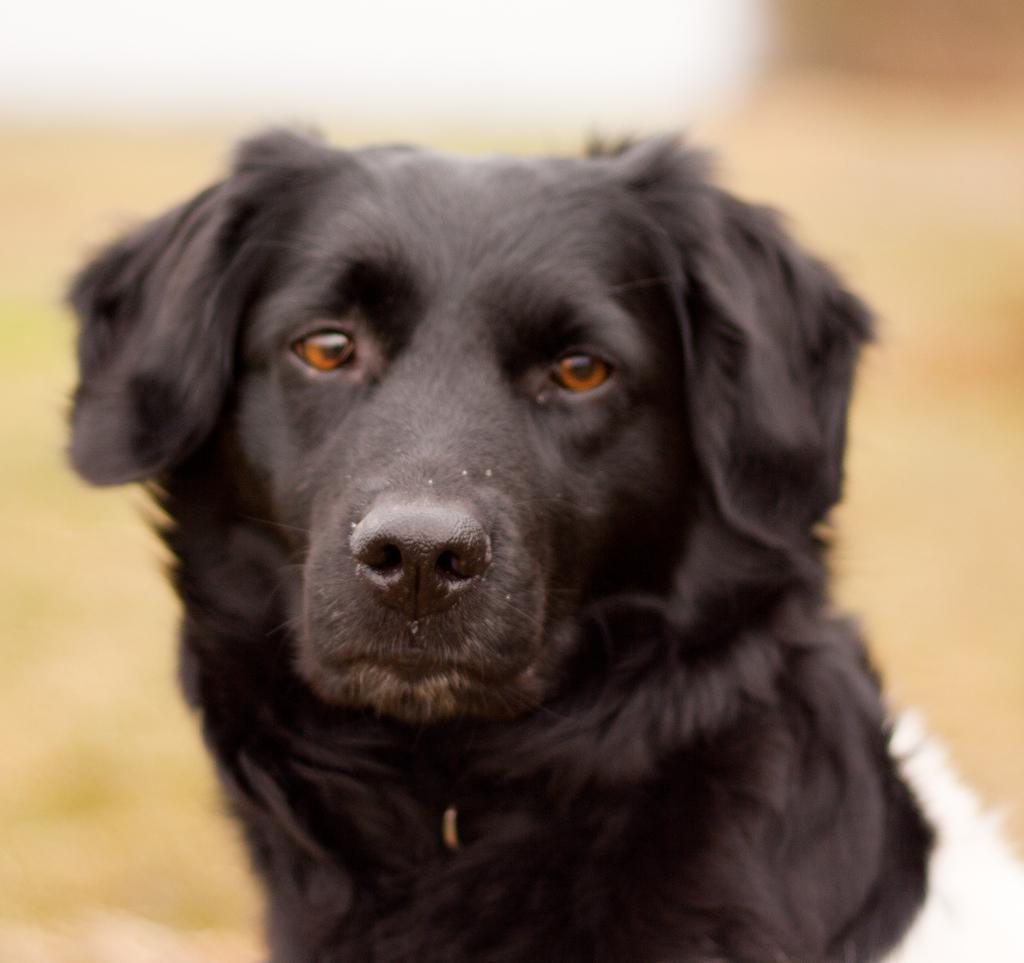In one or two sentences, can you explain what this image depicts? In this image we can see a dog, and the background is blurred. 